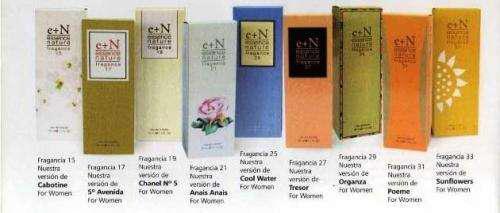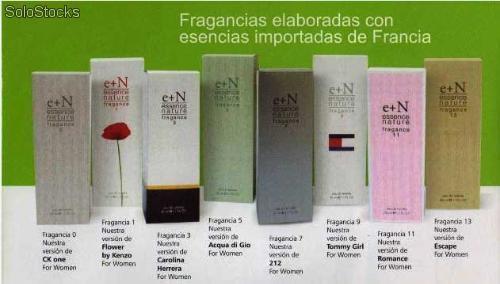The first image is the image on the left, the second image is the image on the right. Considering the images on both sides, is "The box for the product in the image on the left shows a woman's face." valid? Answer yes or no. No. 